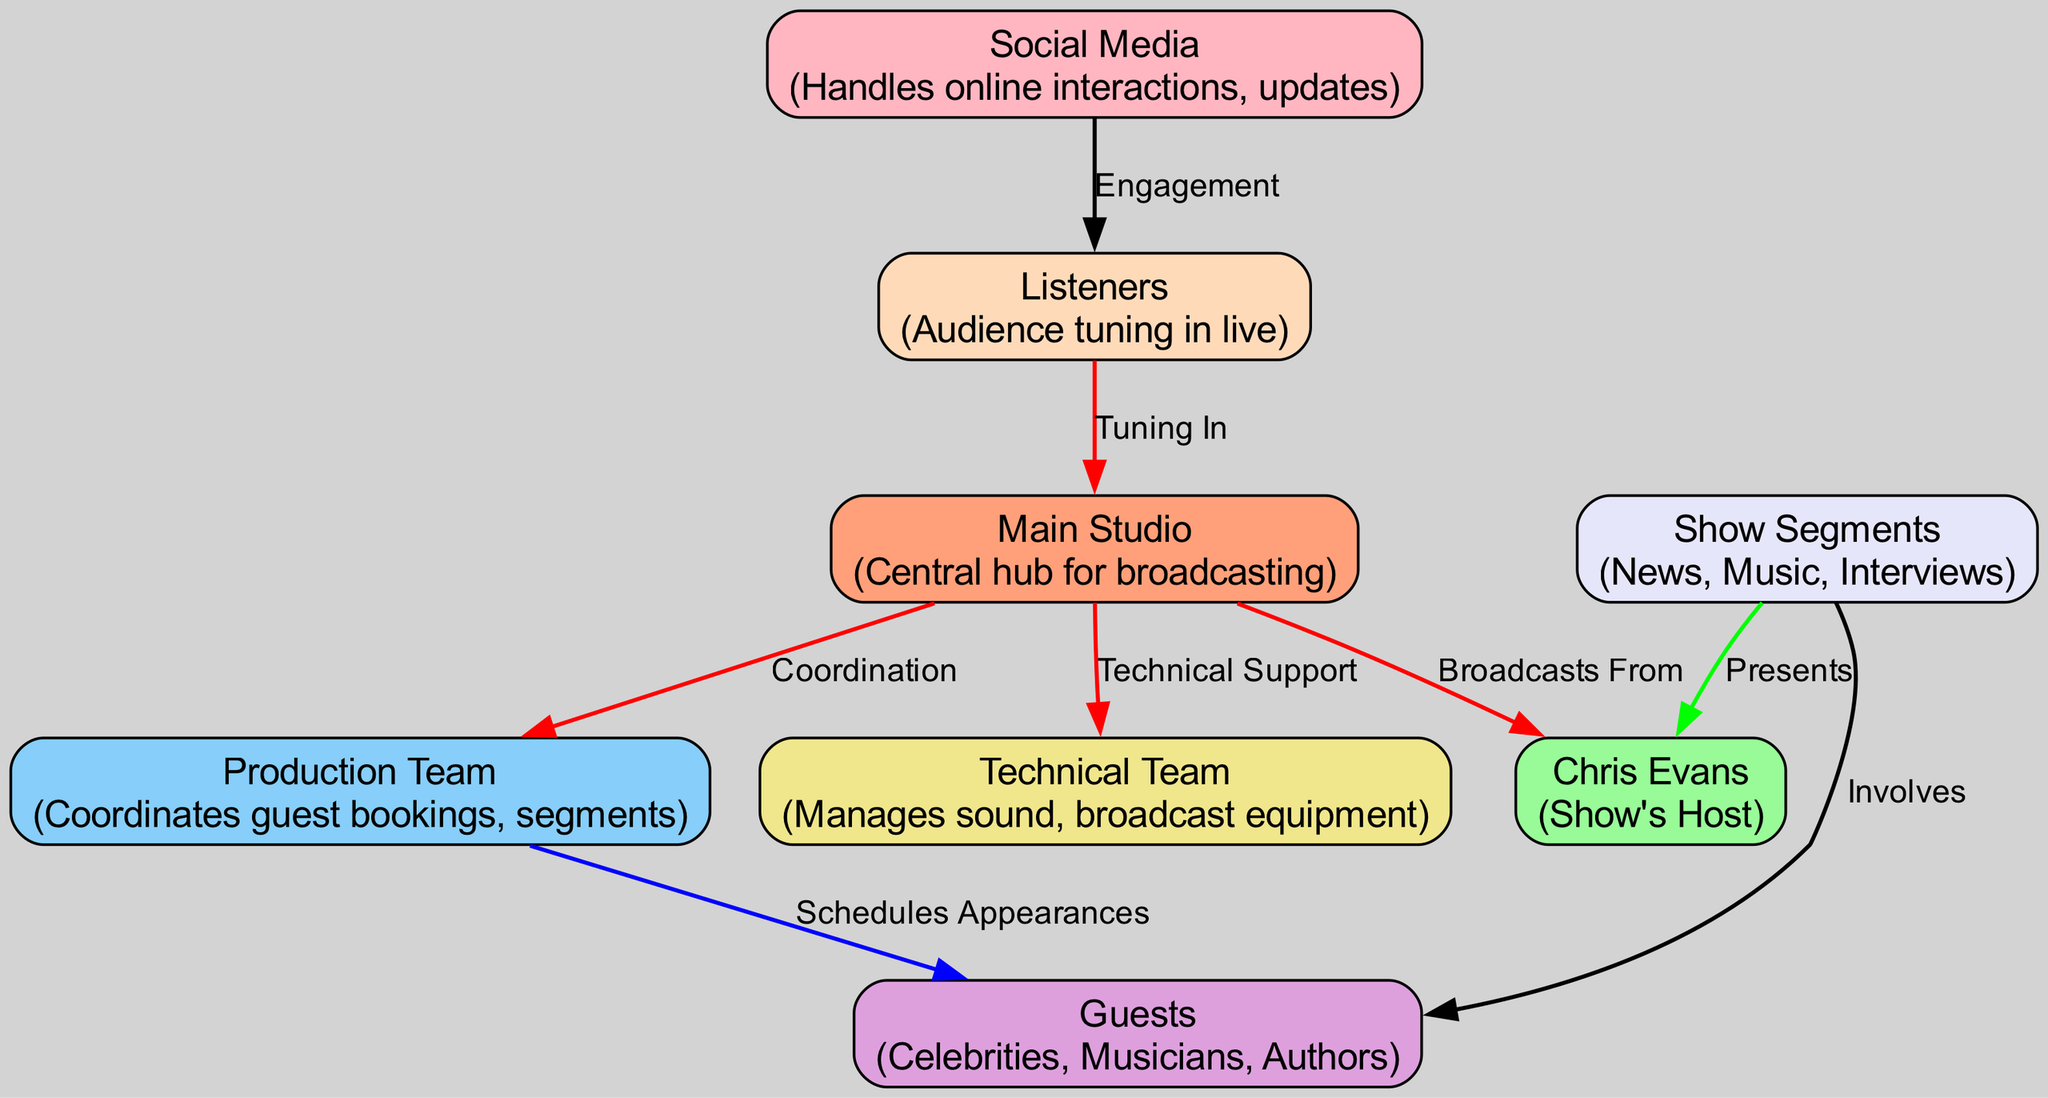What is the central hub for broadcasting? The diagram identifies the "Main Studio" as the central hub for broadcasting. This is a direct label on one of the nodes in the diagram.
Answer: Main Studio Who is the show’s host? The diagram specifies "Chris Evans" as the host of the show. This is shown clearly as a node labeled with his name.
Answer: Chris Evans How many key teams are involved in the show? There are four key teams identified: Production Team, Technical Team, Guests, and Social Media. Counting these nodes gives the total.
Answer: Four What color represents the Technical Team? According to the color map in the diagram, the Technical Team is represented by the color Khaki. This can be verified by looking at the node's color.
Answer: Khaki What is the relationship between the producers and guests? The diagram states that the producers "Schedules Appearances" for the guests, indicating a scheduling relationship between these nodes.
Answer: Schedules Appearances How do listeners interact with the show? Listeners engage with the show through "Tuning In" according to the diagram: this interaction is represented by the arrow leading from the listeners to the main studio.
Answer: Tuning In What segments are included in the show? The show includes segments for News, Music, and Interviews, as indicated by the node labeled "Show Segments" that involves those categories.
Answer: News, Music, Interviews What supports the main studio broadcasting? The main studio is supported by the "Technical Team" and "Production Team," as the edges show connections to these nodes, indicating their support roles.
Answer: Technical Team, Production Team Which team manages online interactions? The "Social Media" team manages online interactions and updates, which is a direct description from the corresponding node.
Answer: Social Media 